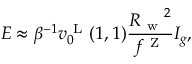Convert formula to latex. <formula><loc_0><loc_0><loc_500><loc_500>E \approx \beta ^ { - 1 } v _ { 0 } ^ { L } ( 1 , 1 ) \frac { { R _ { w } } ^ { 2 } } { f ^ { Z } } I _ { g } ,</formula> 